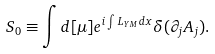Convert formula to latex. <formula><loc_0><loc_0><loc_500><loc_500>S _ { 0 } \equiv \int d [ \mu ] e ^ { i \int L _ { Y M } d x } \delta ( \partial _ { j } A _ { j } ) .</formula> 